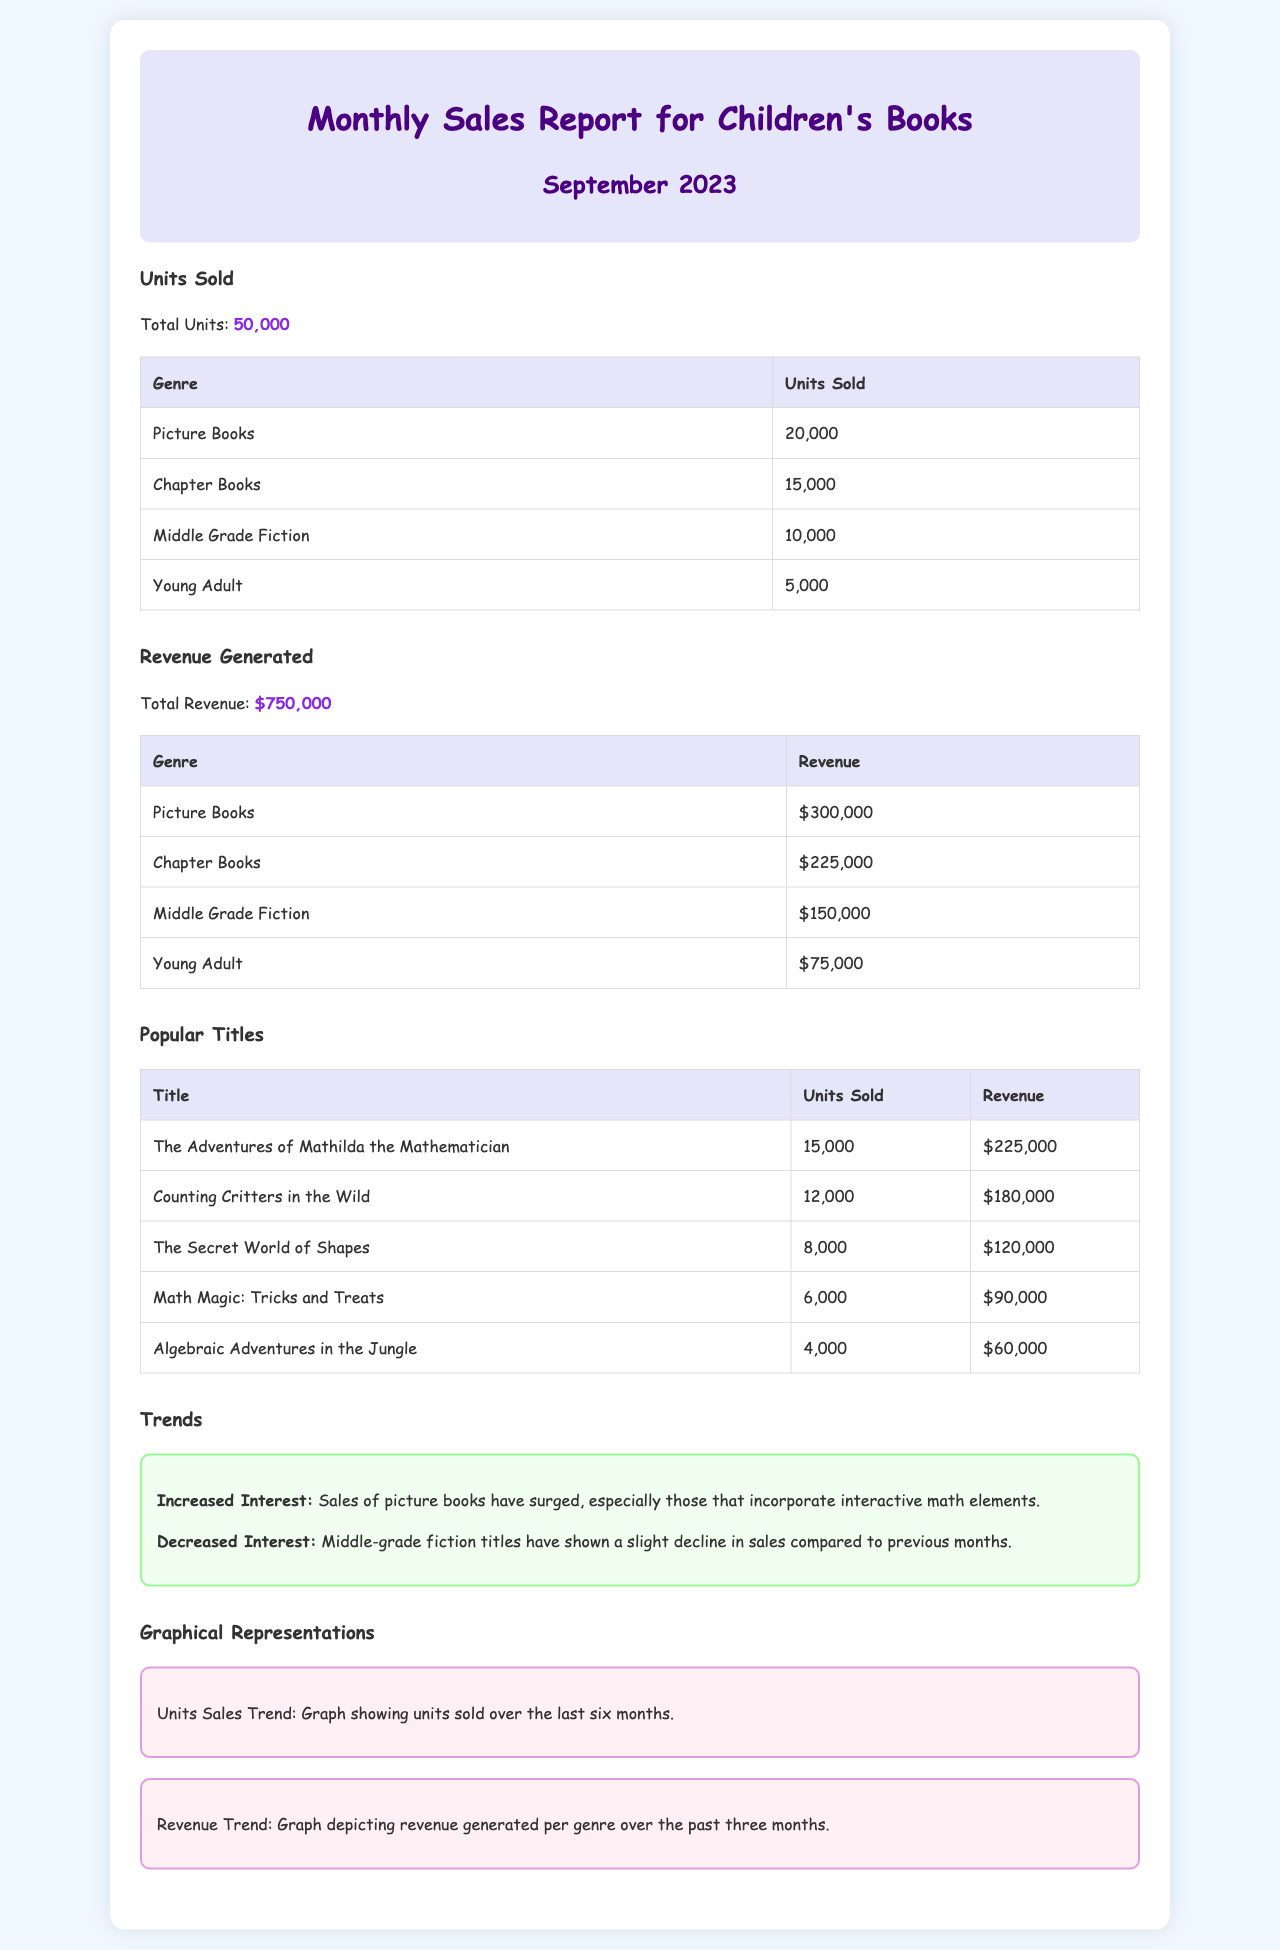What is the total units sold? The total units sold is the sum of all units sold across different genres, which equals 50,000.
Answer: 50,000 What is the total revenue generated? The total revenue generated is the sum of all revenue amounts listed for different genres, which is $750,000.
Answer: $750,000 Which genre sold the most units? The genre that sold the most units according to the document is Picture Books, with 20,000 units sold.
Answer: Picture Books What is the revenue from Chapter Books? The revenue from Chapter Books is specified in the document as $225,000.
Answer: $225,000 How many units were sold for The Adventures of Mathilda the Mathematician? The document states that The Adventures of Mathilda the Mathematician sold 15,000 units.
Answer: 15,000 What trend is noted regarding Middle Grade Fiction sales? The document mentions that Middle Grade Fiction titles have shown a slight decline in sales compared to previous months.
Answer: Slight decline What was the revenue generated from Young Adult books? The revenue generated from Young Adult books is listed as $75,000 in the document.
Answer: $75,000 What popular title had the lowest sales? According to the document, the popular title with the lowest sales is Algebraic Adventures in the Jungle, with 4,000 units sold.
Answer: Algebraic Adventures in the Jungle How many units were sold for Counting Critters in the Wild? The document states that Counting Critters in the Wild sold 12,000 units.
Answer: 12,000 